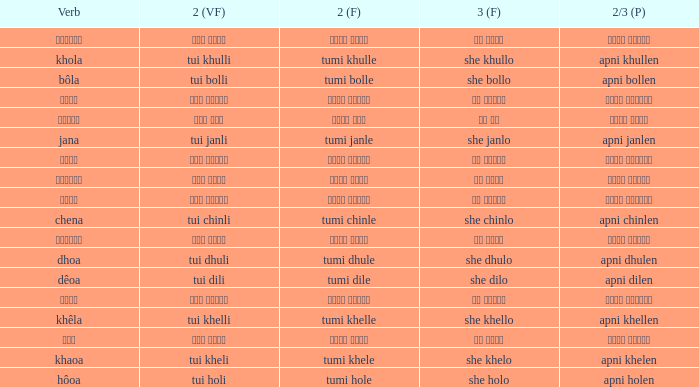What is the 2(vf) for তুমি বললে? তুই বললি. 